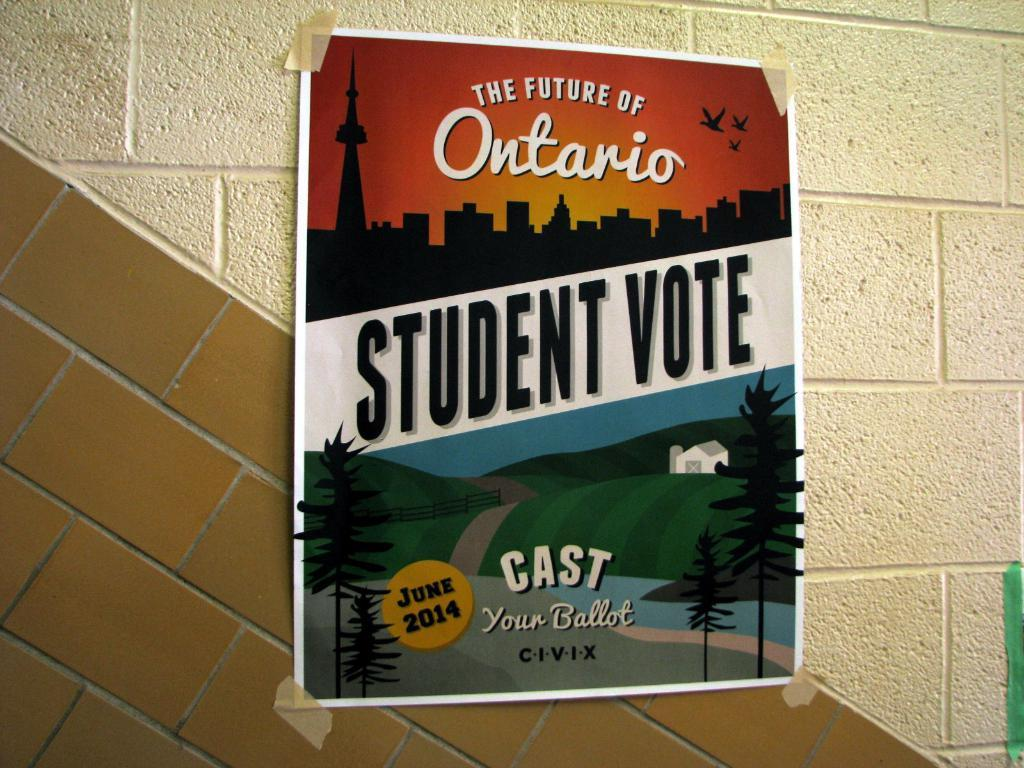<image>
Create a compact narrative representing the image presented. Poster taped on a wall that says "The Future of Ontario". 